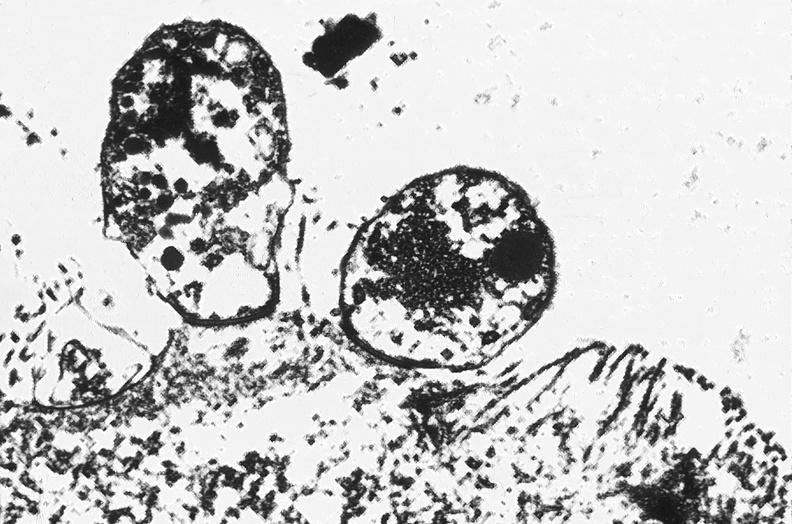does foot show colon, cryptosporidia?
Answer the question using a single word or phrase. No 